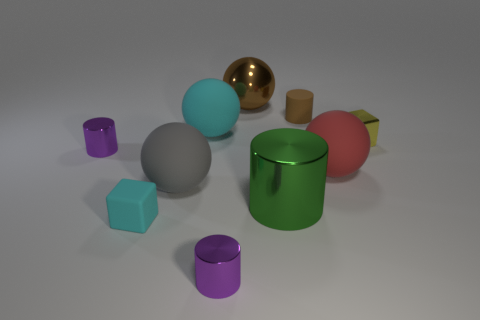Subtract all cylinders. How many objects are left? 6 Add 8 tiny yellow things. How many tiny yellow things are left? 9 Add 9 small cyan blocks. How many small cyan blocks exist? 10 Subtract 0 red cylinders. How many objects are left? 10 Subtract all small rubber cylinders. Subtract all large metal objects. How many objects are left? 7 